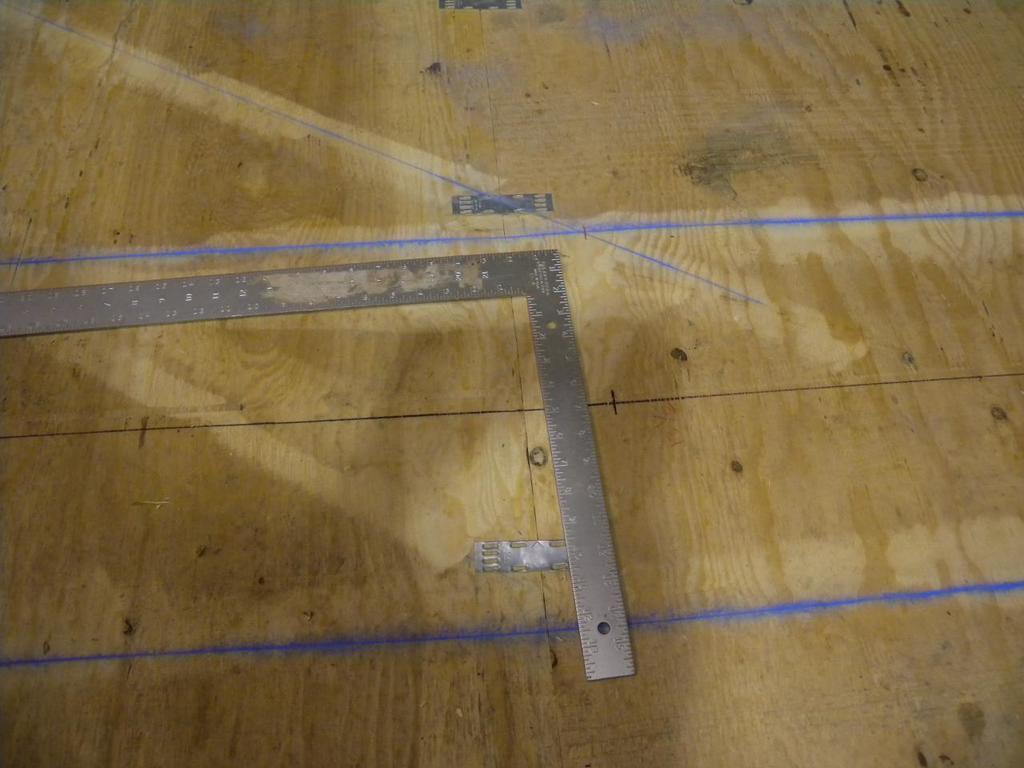Please provide a concise description of this image. In this image we can see a measuring scale and margins on the wooden surface. 